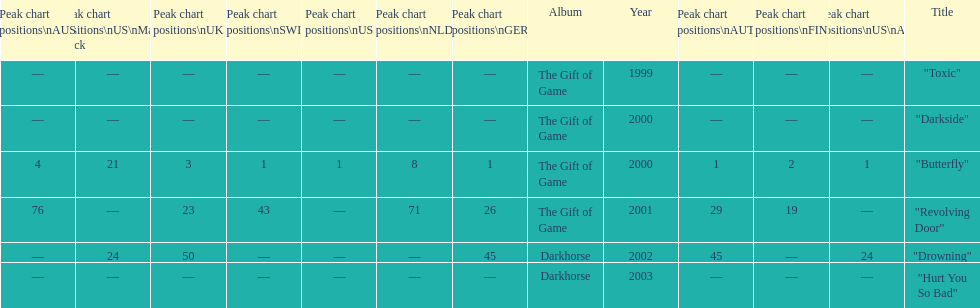When did "drowning" peak at 24 in the us alternate group? 2002. 